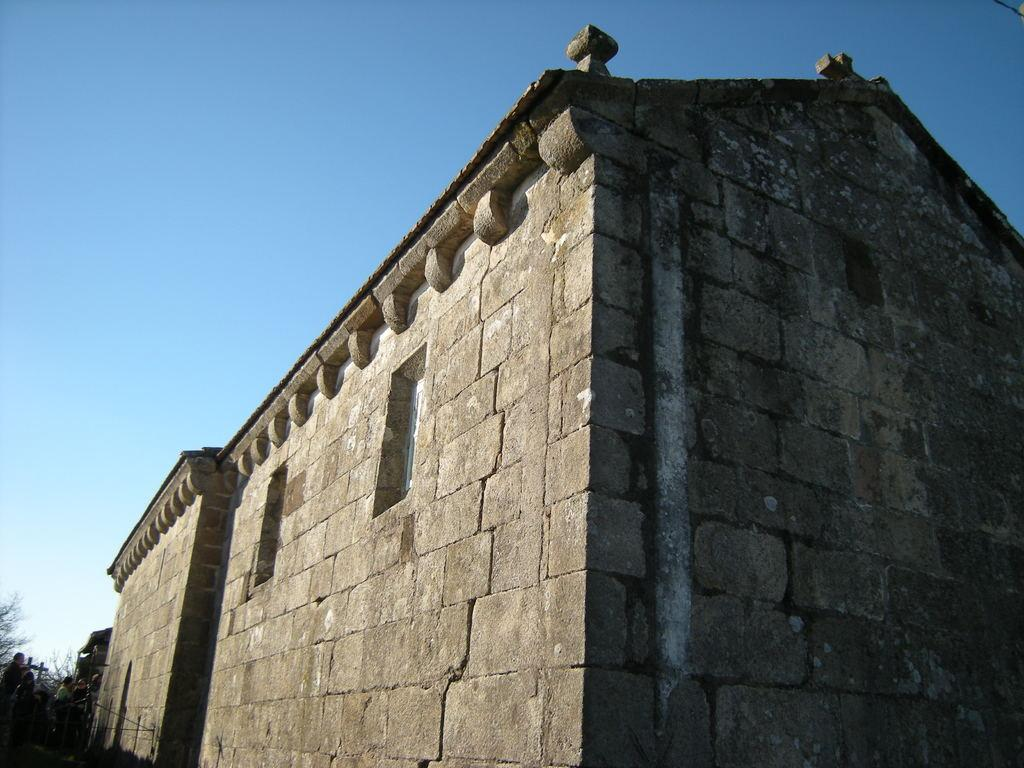What type of building is featured in the image? There is a building with a stone wall in the image. Where are the people located in the image? The people are in the left bottom corner of the image. What other natural elements can be seen in the image? There are trees in the image. What is visible in the background of the image? The sky is visible in the background of the image. What type of credit can be seen being offered to the people in the image? There is no credit being offered in the image; it only features a building, people, trees, and the sky. 